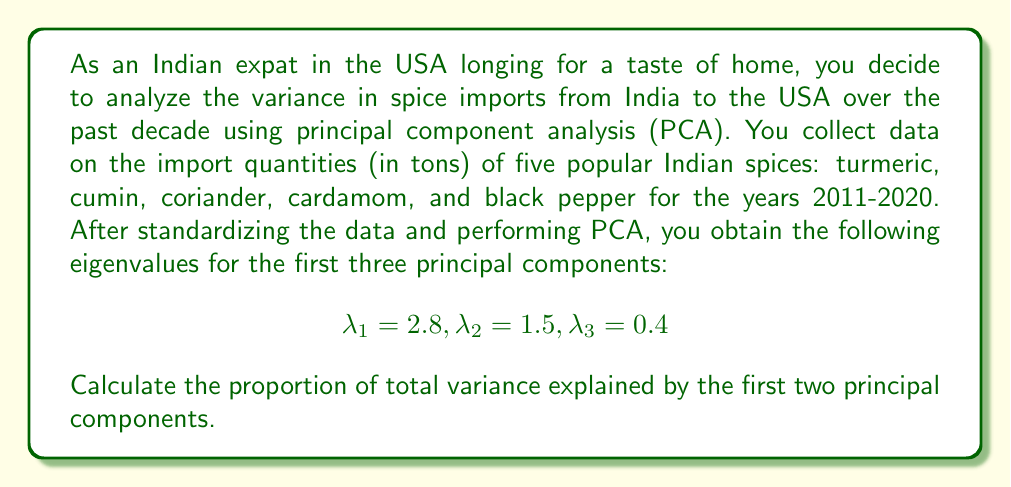Can you answer this question? To solve this problem, we'll follow these steps:

1) First, recall that in PCA, the total variance is equal to the number of variables (spices in this case) when using standardized data. Here, we have 5 spices, so the total variance is 5.

2) The variance explained by each principal component is equal to its eigenvalue.

3) To calculate the proportion of variance explained by the first two principal components, we need to:
   a) Sum the eigenvalues of the first two components
   b) Divide this sum by the total variance

4) Let's perform the calculation:

   Sum of first two eigenvalues: $\lambda_1 + \lambda_2 = 2.8 + 1.5 = 4.3$

   Proportion of variance explained:
   
   $$\frac{\lambda_1 + \lambda_2}{\text{Total Variance}} = \frac{4.3}{5} = 0.86$$

5) To convert to a percentage, multiply by 100:

   $0.86 \times 100 = 86\%$

Therefore, the first two principal components explain 86% of the total variance in spice imports from India to the USA over the past decade.
Answer: 86% 